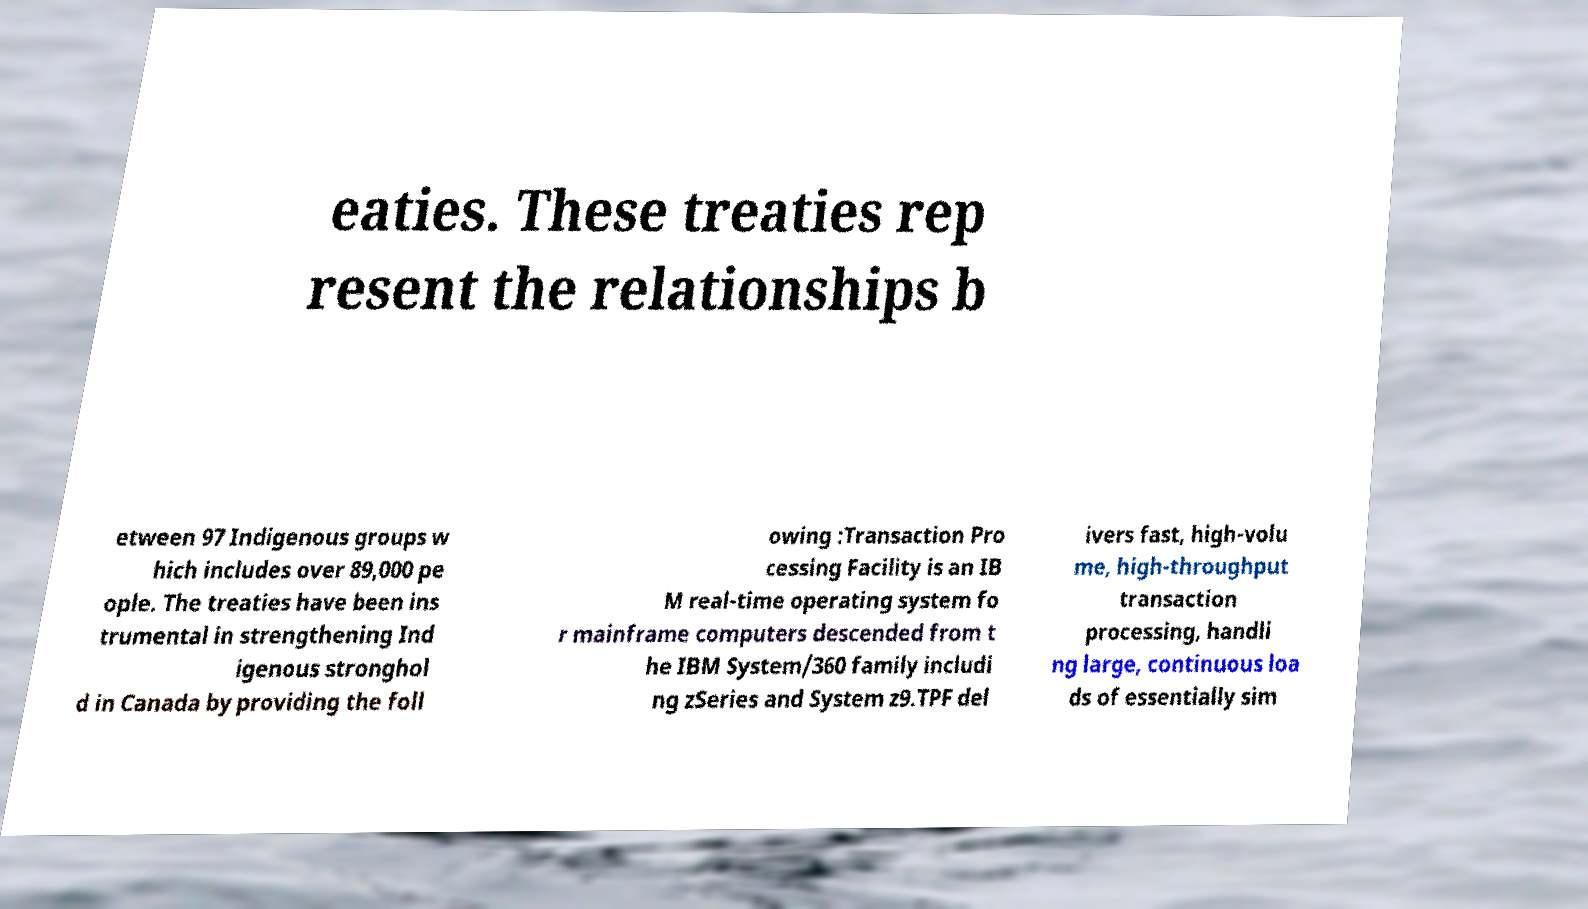Please read and relay the text visible in this image. What does it say? eaties. These treaties rep resent the relationships b etween 97 Indigenous groups w hich includes over 89,000 pe ople. The treaties have been ins trumental in strengthening Ind igenous stronghol d in Canada by providing the foll owing :Transaction Pro cessing Facility is an IB M real-time operating system fo r mainframe computers descended from t he IBM System/360 family includi ng zSeries and System z9.TPF del ivers fast, high-volu me, high-throughput transaction processing, handli ng large, continuous loa ds of essentially sim 